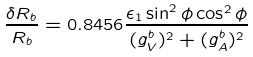<formula> <loc_0><loc_0><loc_500><loc_500>\frac { \delta R _ { b } } { R _ { b } } = 0 . 8 4 5 6 \frac { \epsilon _ { 1 } \sin ^ { 2 } \phi \cos ^ { 2 } \phi } { ( g _ { V } ^ { b } ) ^ { 2 } + ( g _ { A } ^ { b } ) ^ { 2 } }</formula> 